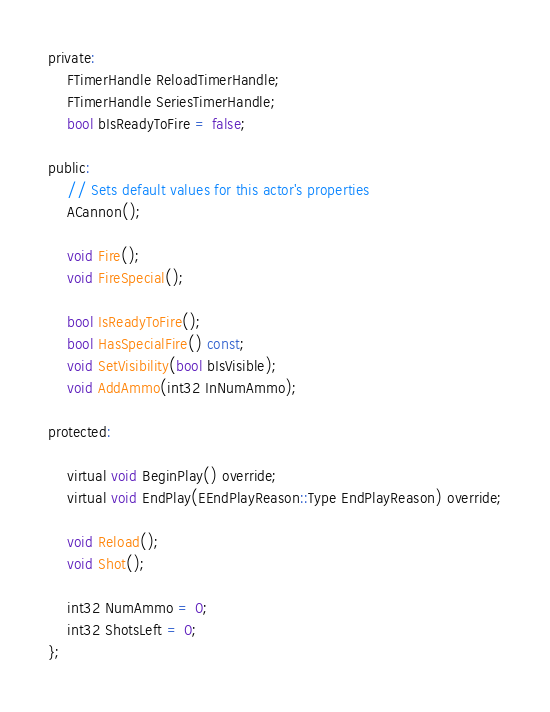Convert code to text. <code><loc_0><loc_0><loc_500><loc_500><_C_>
private:
	FTimerHandle ReloadTimerHandle;
	FTimerHandle SeriesTimerHandle;
	bool bIsReadyToFire = false;

public:	
	// Sets default values for this actor's properties
	ACannon();

	void Fire();
	void FireSpecial();

	bool IsReadyToFire();
	bool HasSpecialFire() const;
	void SetVisibility(bool bIsVisible);
	void AddAmmo(int32 InNumAmmo);

protected:

	virtual void BeginPlay() override;
	virtual void EndPlay(EEndPlayReason::Type EndPlayReason) override;

	void Reload();
	void Shot();

	int32 NumAmmo = 0;
	int32 ShotsLeft = 0;
};
</code> 